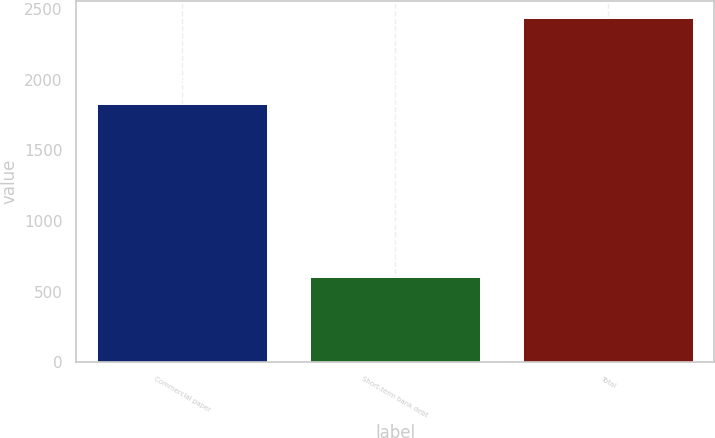Convert chart to OTSL. <chart><loc_0><loc_0><loc_500><loc_500><bar_chart><fcel>Commercial paper<fcel>Short-term bank debt<fcel>Total<nl><fcel>1832<fcel>607<fcel>2439<nl></chart> 